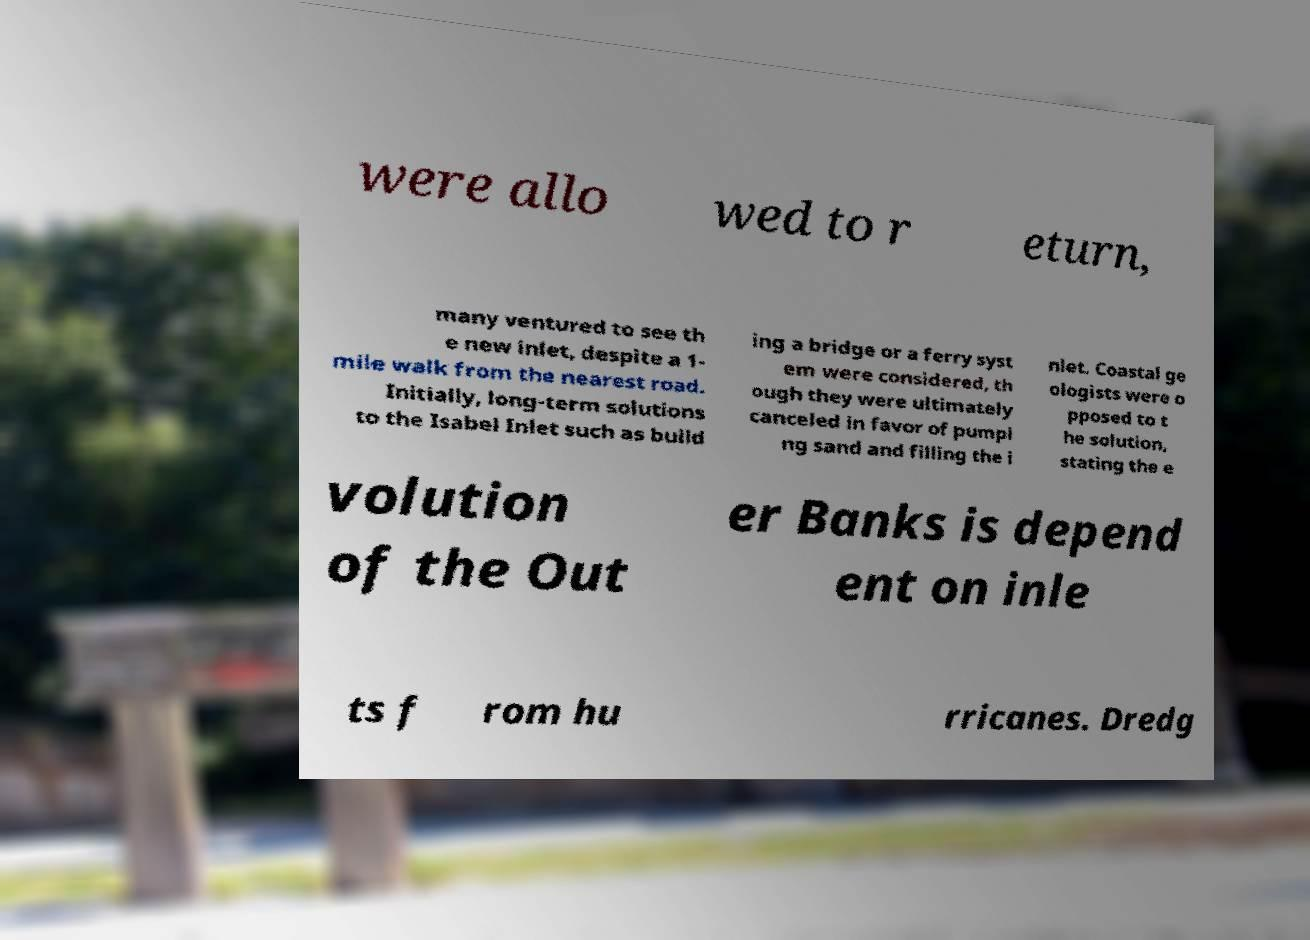Can you read and provide the text displayed in the image?This photo seems to have some interesting text. Can you extract and type it out for me? were allo wed to r eturn, many ventured to see th e new inlet, despite a 1- mile walk from the nearest road. Initially, long-term solutions to the Isabel Inlet such as build ing a bridge or a ferry syst em were considered, th ough they were ultimately canceled in favor of pumpi ng sand and filling the i nlet. Coastal ge ologists were o pposed to t he solution, stating the e volution of the Out er Banks is depend ent on inle ts f rom hu rricanes. Dredg 